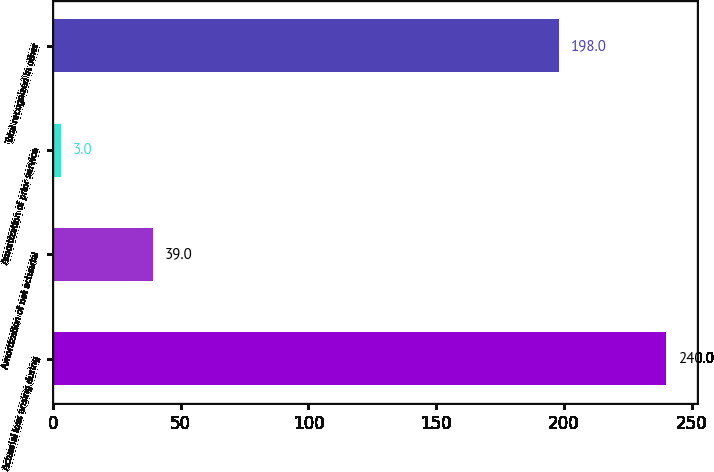<chart> <loc_0><loc_0><loc_500><loc_500><bar_chart><fcel>Actuarial loss arising during<fcel>Amortization of net actuarial<fcel>Amortization of prior service<fcel>Total recognized in other<nl><fcel>240<fcel>39<fcel>3<fcel>198<nl></chart> 